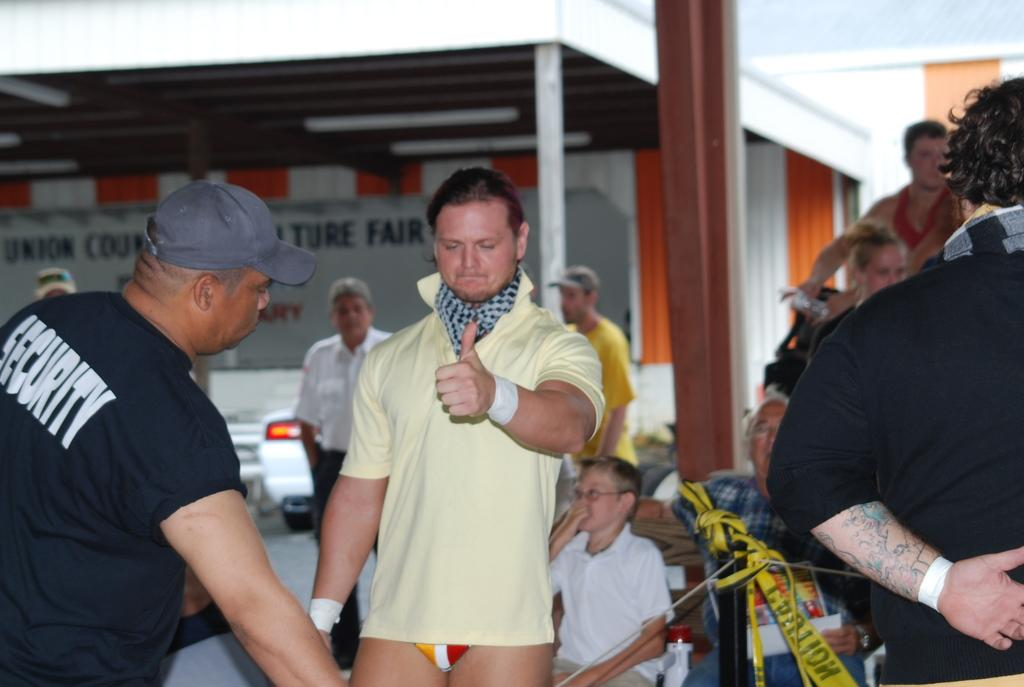What are the people in the image doing? The persons standing on the ground are visible in the image. Can you describe the background of the image? In the background, there are persons, chairs, vehicles, lights, and a wall present. What type of objects are visible in the background that are not people? Chairs, vehicles, lights, and a wall are visible in the background. What type of wrench is being used by the person in the image? There is no wrench present in the image. Can you describe the arm of the person's friend in the image? There is no friend or arm mentioned in the image; it only shows persons standing on the ground and objects in the background. 